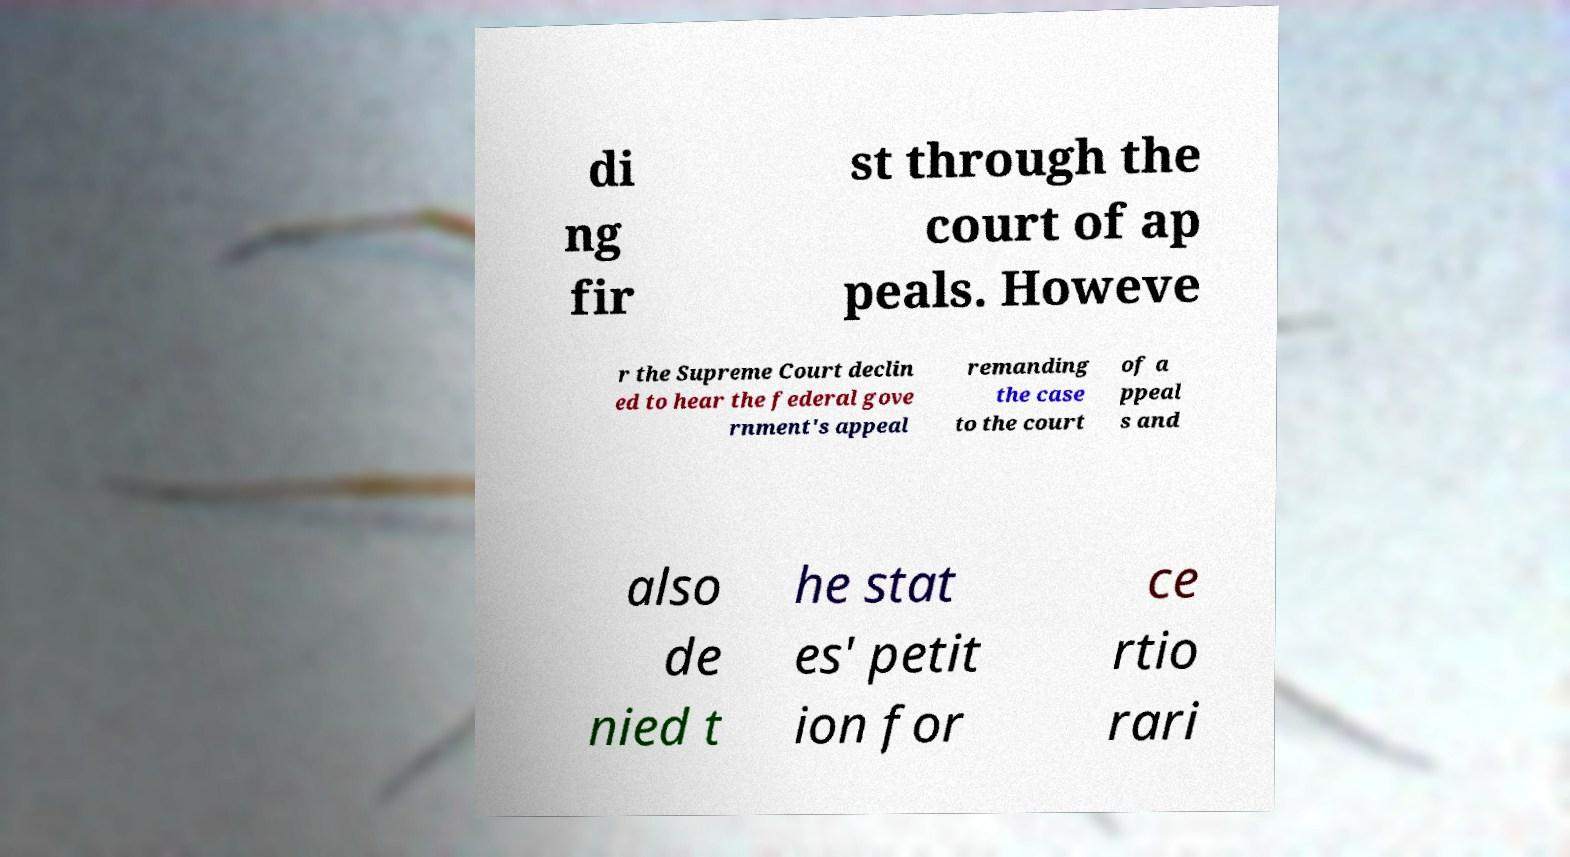Please identify and transcribe the text found in this image. di ng fir st through the court of ap peals. Howeve r the Supreme Court declin ed to hear the federal gove rnment's appeal remanding the case to the court of a ppeal s and also de nied t he stat es' petit ion for ce rtio rari 